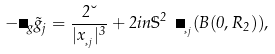Convert formula to latex. <formula><loc_0><loc_0><loc_500><loc_500>- \Delta _ { g } \tilde { g } _ { j } = \frac { 2 \lambda } { | x _ { \xi _ { j } } | ^ { 3 } } + 2 i n \mathbb { S } ^ { 2 } \ \Pi _ { \xi _ { j } } ( B ( 0 , R _ { 2 } ) ) ,</formula> 